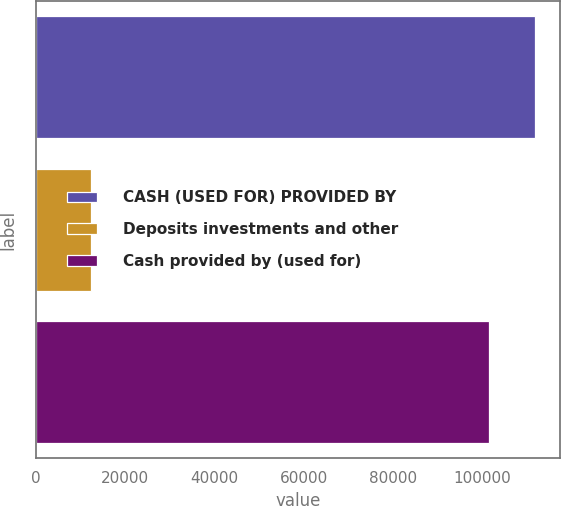Convert chart. <chart><loc_0><loc_0><loc_500><loc_500><bar_chart><fcel>CASH (USED FOR) PROVIDED BY<fcel>Deposits investments and other<fcel>Cash provided by (used for)<nl><fcel>111743<fcel>12248<fcel>101442<nl></chart> 